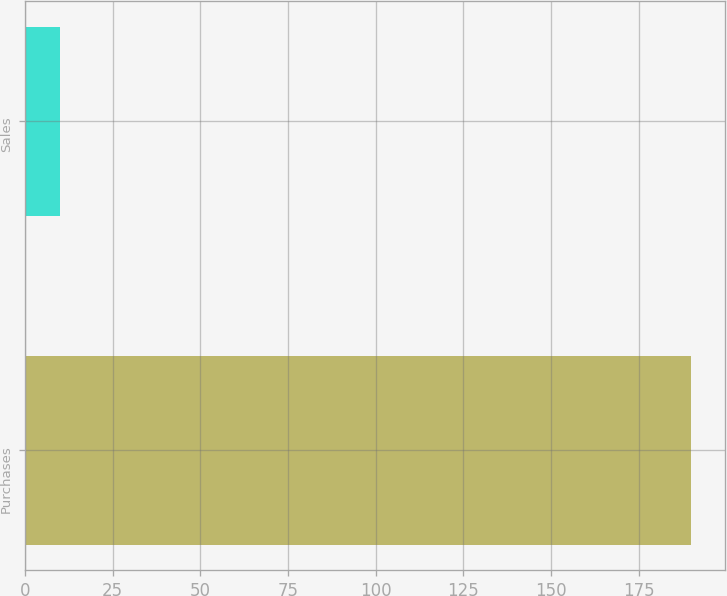Convert chart to OTSL. <chart><loc_0><loc_0><loc_500><loc_500><bar_chart><fcel>Purchases<fcel>Sales<nl><fcel>190<fcel>10<nl></chart> 